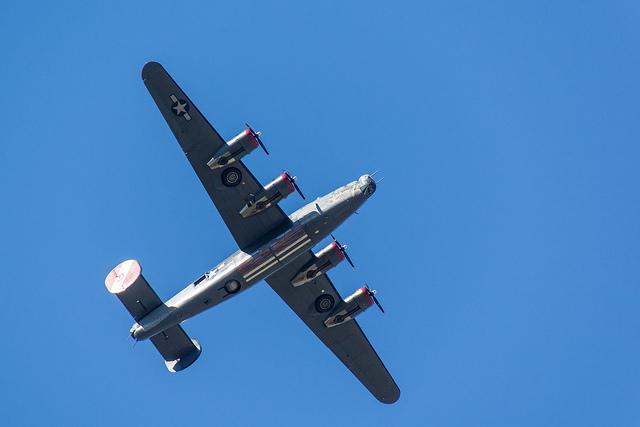What color is the plane?
Concise answer only. Gray. Is this a passenger plane?
Be succinct. No. What color is the plane in the sky?
Give a very brief answer. Gray. What are the plane's colors?
Give a very brief answer. Silver. How is the weather?
Concise answer only. Clear. What is in the sky?
Be succinct. Plane. Are there any clouds in the sky?
Give a very brief answer. No. 